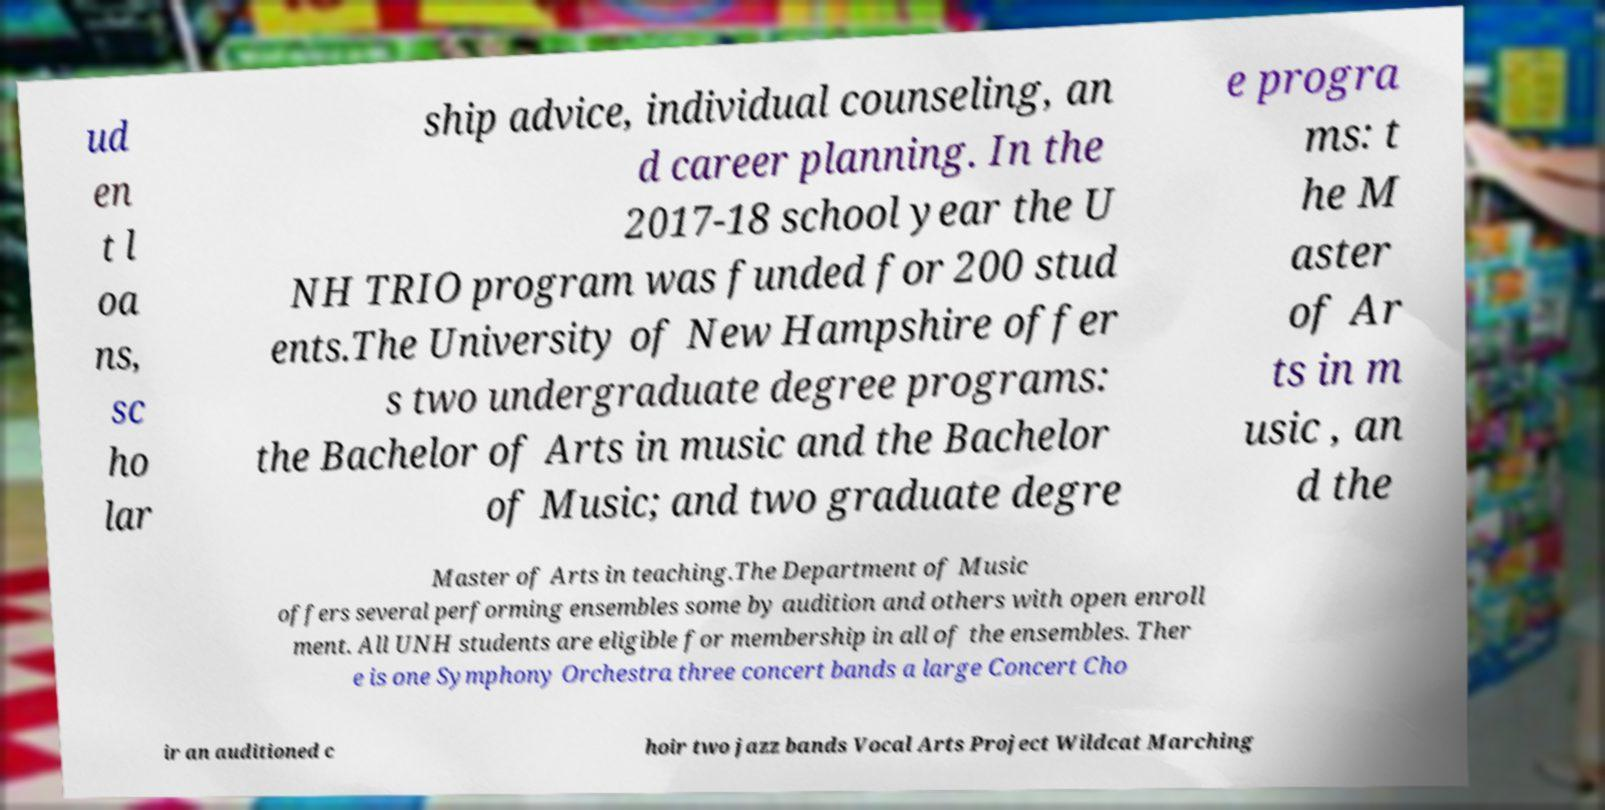For documentation purposes, I need the text within this image transcribed. Could you provide that? ud en t l oa ns, sc ho lar ship advice, individual counseling, an d career planning. In the 2017-18 school year the U NH TRIO program was funded for 200 stud ents.The University of New Hampshire offer s two undergraduate degree programs: the Bachelor of Arts in music and the Bachelor of Music; and two graduate degre e progra ms: t he M aster of Ar ts in m usic , an d the Master of Arts in teaching.The Department of Music offers several performing ensembles some by audition and others with open enroll ment. All UNH students are eligible for membership in all of the ensembles. Ther e is one Symphony Orchestra three concert bands a large Concert Cho ir an auditioned c hoir two jazz bands Vocal Arts Project Wildcat Marching 